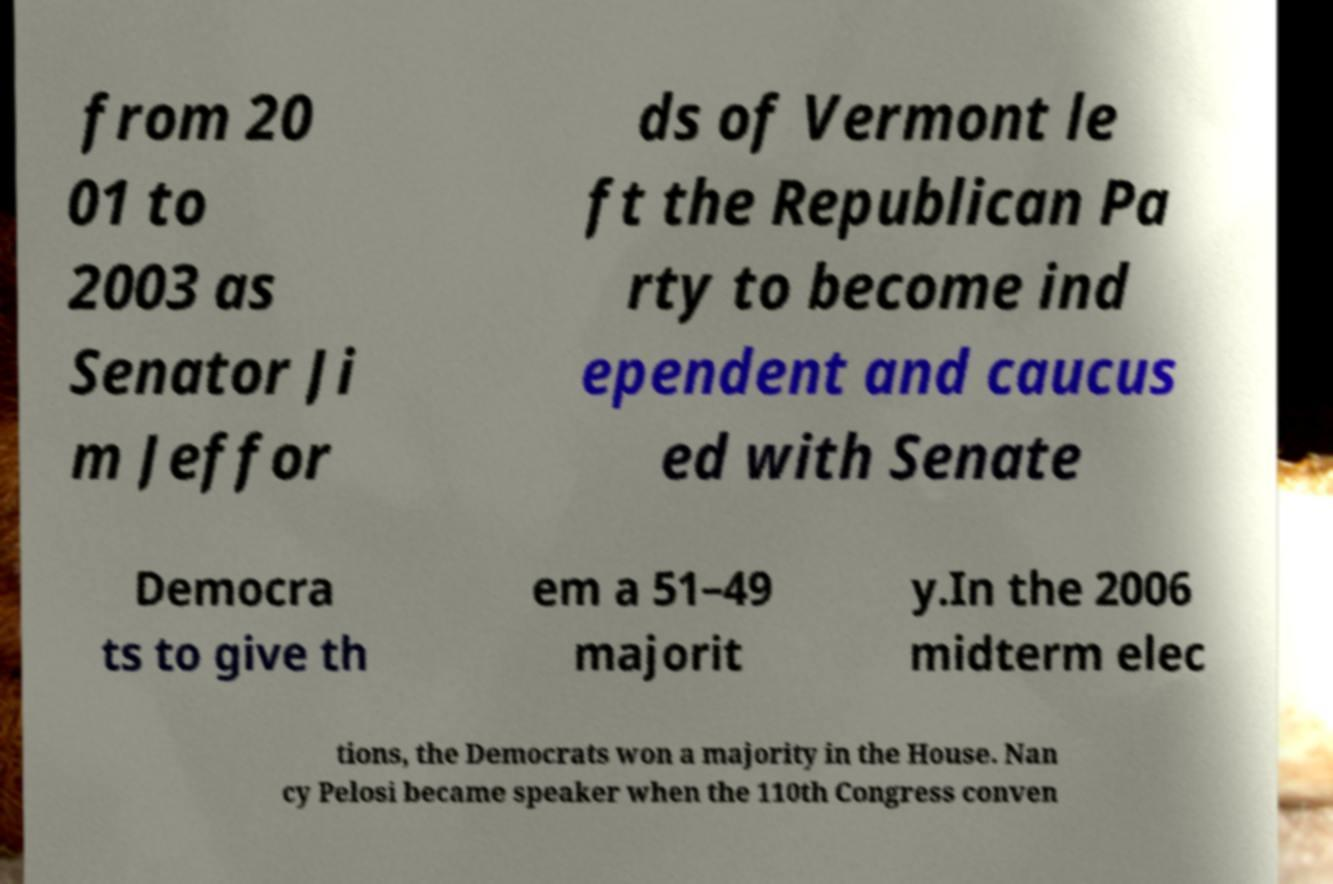What messages or text are displayed in this image? I need them in a readable, typed format. from 20 01 to 2003 as Senator Ji m Jeffor ds of Vermont le ft the Republican Pa rty to become ind ependent and caucus ed with Senate Democra ts to give th em a 51–49 majorit y.In the 2006 midterm elec tions, the Democrats won a majority in the House. Nan cy Pelosi became speaker when the 110th Congress conven 